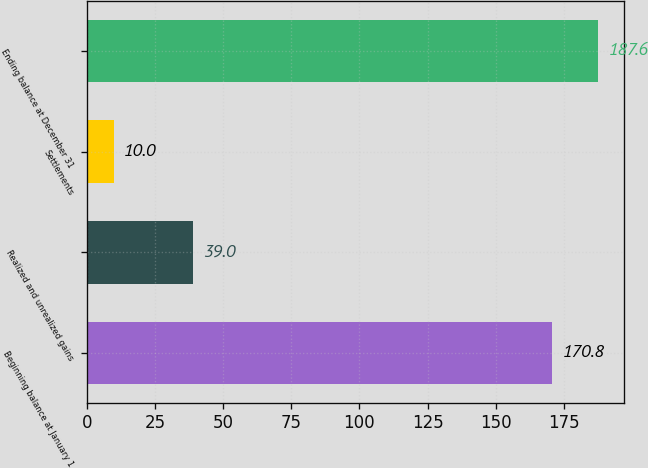Convert chart. <chart><loc_0><loc_0><loc_500><loc_500><bar_chart><fcel>Beginning balance at January 1<fcel>Realized and unrealized gains<fcel>Settlements<fcel>Ending balance at December 31<nl><fcel>170.8<fcel>39<fcel>10<fcel>187.6<nl></chart> 